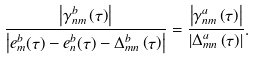<formula> <loc_0><loc_0><loc_500><loc_500>\frac { { \left | { \gamma _ { n m } ^ { b } \left ( \tau \right ) } \right | } } { { \left | { e _ { m } ^ { b } ( \tau ) - e _ { n } ^ { b } ( \tau ) - \Delta _ { m n } ^ { b } \left ( \tau \right ) } \right | } } = \frac { { \left | { \gamma _ { n m } ^ { a } \left ( \tau \right ) } \right | } } { { \left | { \Delta _ { m n } ^ { a } \left ( \tau \right ) } \right | } } .</formula> 